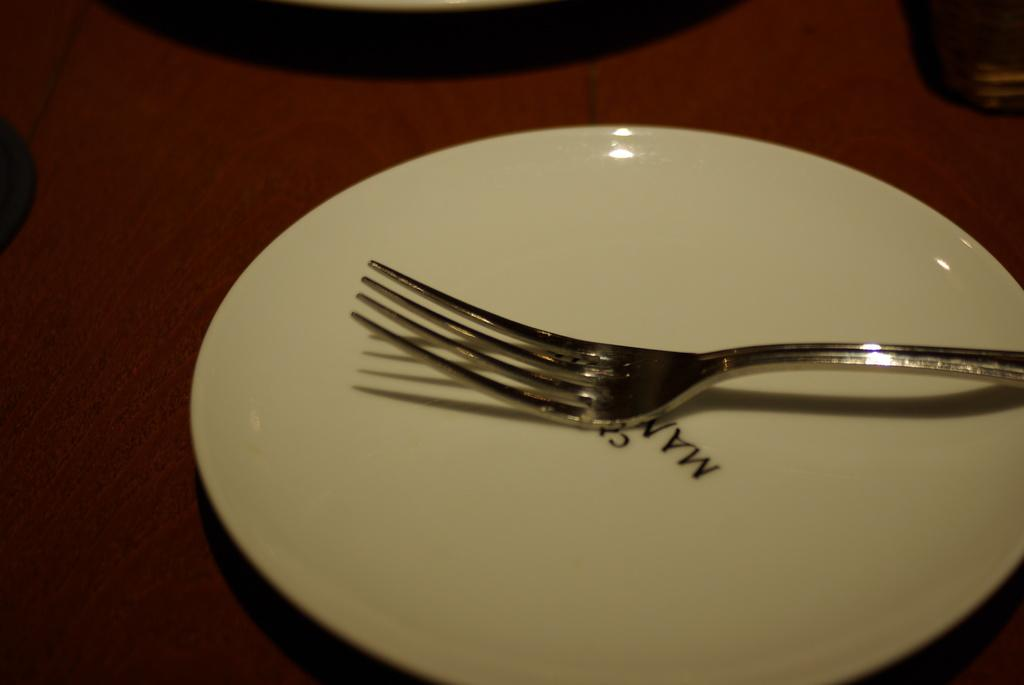What utensil is placed on a plate in the image? There is a fork on a plate in the image. What type of container is visible in the top right corner of the image? There appears to be a glass in the top right corner of the image. What can be seen in the background of the image? There is a table in the background of the image. What is written or printed on the plate? There is text on the plate. How many trees are visible in the image? There are no trees visible in the image; it only shows a fork on a plate, a glass, a table, and text on the plate. 